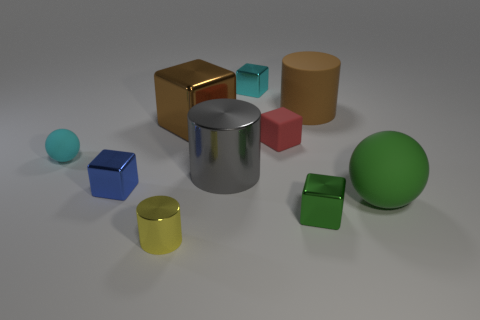There is a small ball left of the block that is in front of the big green matte object; how many brown matte cylinders are in front of it?
Give a very brief answer. 0. What number of big gray shiny things are in front of the big gray metal cylinder?
Make the answer very short. 0. There is a cylinder behind the tiny matte thing that is to the right of the cyan matte sphere; what is its color?
Offer a terse response. Brown. How many other objects are the same material as the gray object?
Your answer should be compact. 5. Are there an equal number of tiny matte spheres on the right side of the green shiny thing and metallic things?
Your answer should be very brief. No. There is a small cyan object that is behind the tiny cyan object that is in front of the shiny block that is behind the matte cylinder; what is its material?
Offer a terse response. Metal. The matte thing on the left side of the blue metallic block is what color?
Your response must be concise. Cyan. There is a shiny block to the right of the cyan thing that is to the right of the gray shiny cylinder; what size is it?
Keep it short and to the point. Small. Are there an equal number of small yellow objects that are behind the small green block and green objects that are behind the tiny red matte block?
Give a very brief answer. Yes. There is a large cylinder that is the same material as the small sphere; what is its color?
Keep it short and to the point. Brown. 